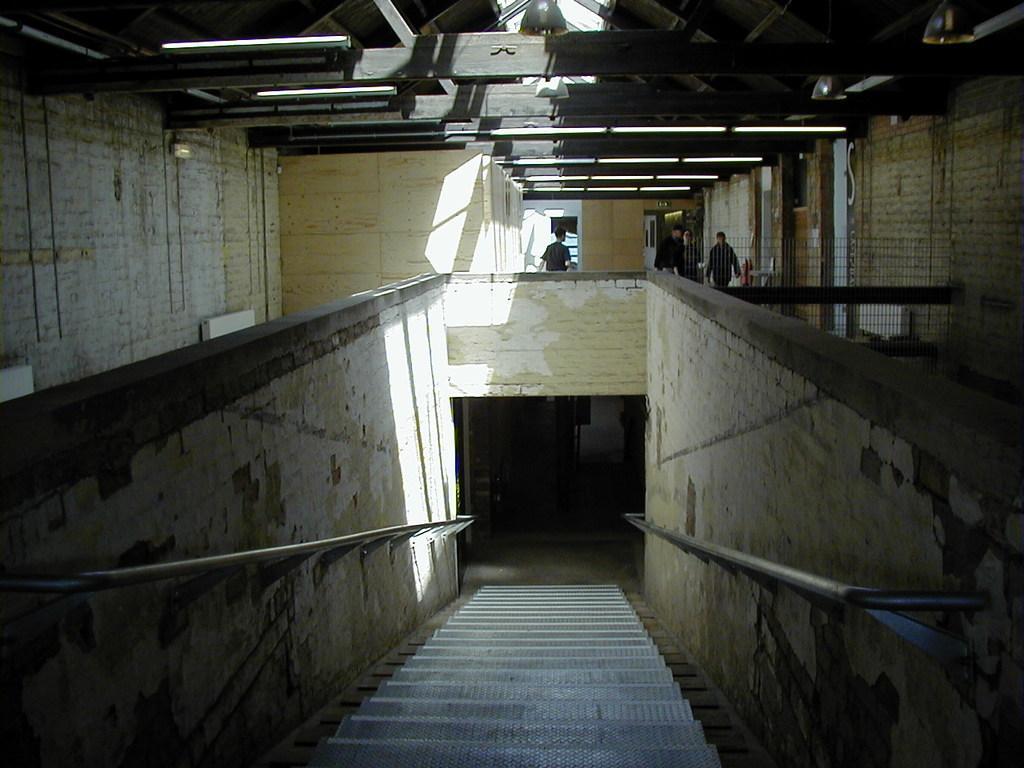Could you give a brief overview of what you see in this image? In this image in front there are stairs. On both right and left side of the image there are walls and we can see a metal fence. On the backside there are people walking in the building. On top of the roof there are lights. 